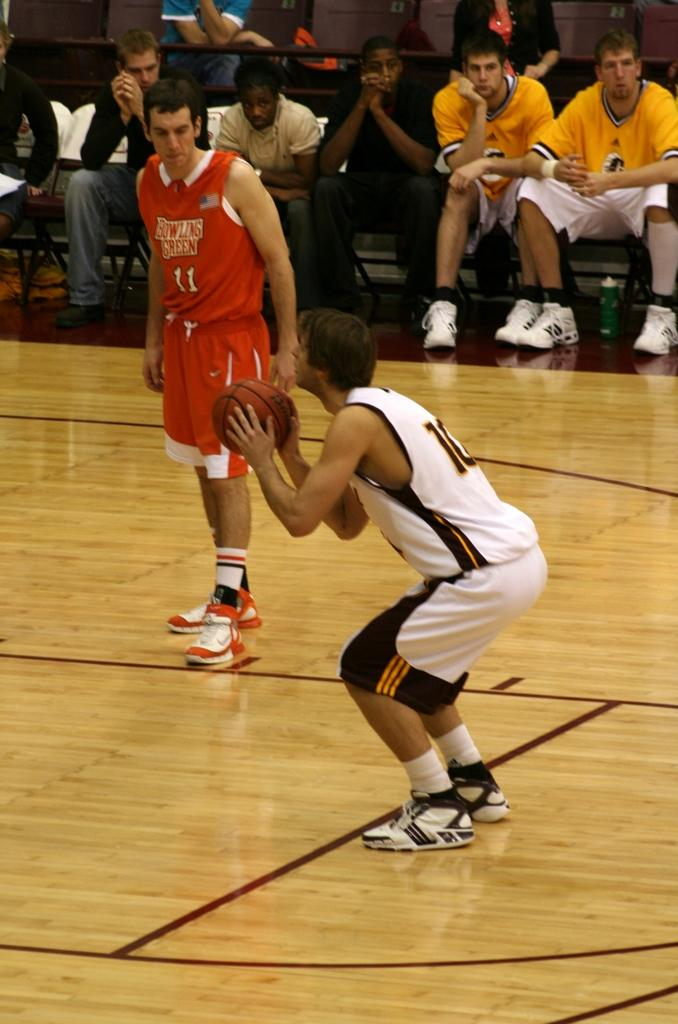What is the person in the image holding? The person in the image is holding a ball. Can you describe the position of the second person in the image? There is another person standing beside the first person. What can be seen in the background of the image? There are spectators in the background of the image. What type of honey is being poured from the vessel in the image? There is no vessel or honey present in the image. What calculations is the calculator performing in the image? There is no calculator present in the image. 